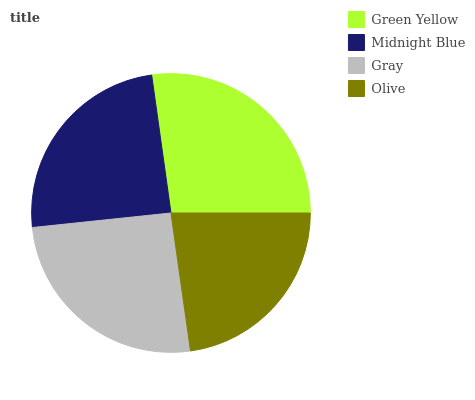Is Olive the minimum?
Answer yes or no. Yes. Is Green Yellow the maximum?
Answer yes or no. Yes. Is Midnight Blue the minimum?
Answer yes or no. No. Is Midnight Blue the maximum?
Answer yes or no. No. Is Green Yellow greater than Midnight Blue?
Answer yes or no. Yes. Is Midnight Blue less than Green Yellow?
Answer yes or no. Yes. Is Midnight Blue greater than Green Yellow?
Answer yes or no. No. Is Green Yellow less than Midnight Blue?
Answer yes or no. No. Is Gray the high median?
Answer yes or no. Yes. Is Midnight Blue the low median?
Answer yes or no. Yes. Is Green Yellow the high median?
Answer yes or no. No. Is Gray the low median?
Answer yes or no. No. 